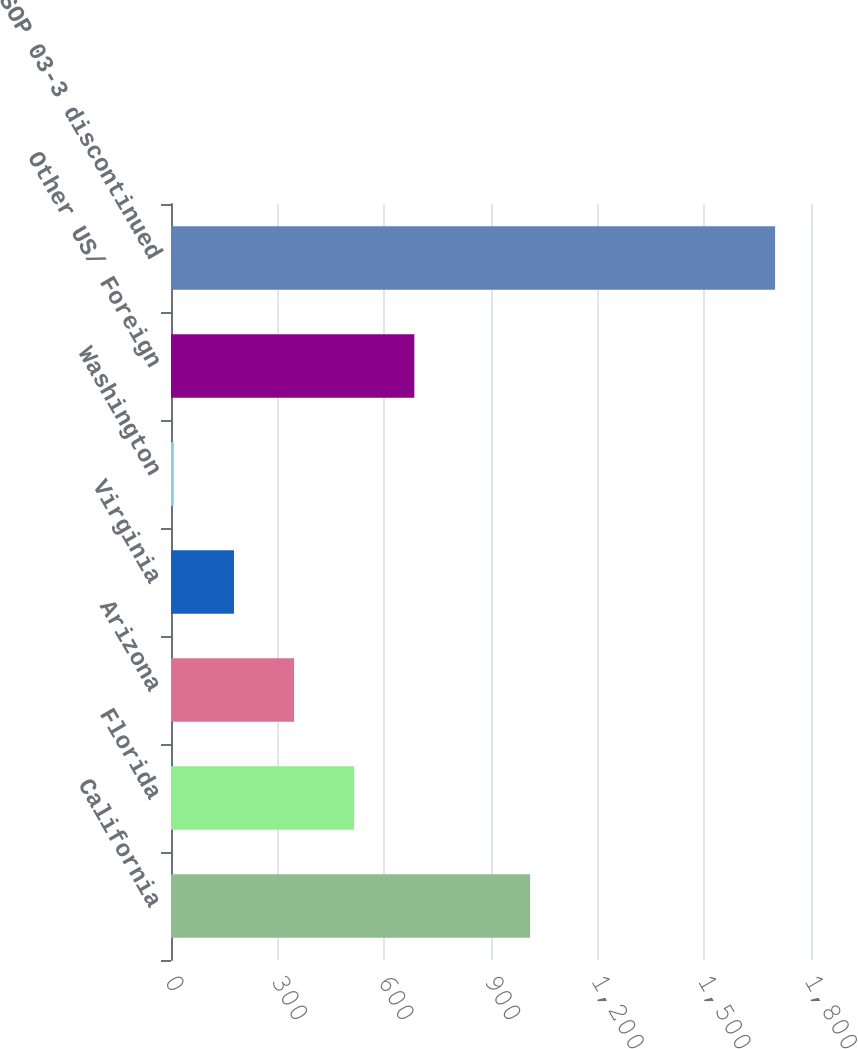Convert chart to OTSL. <chart><loc_0><loc_0><loc_500><loc_500><bar_chart><fcel>California<fcel>Florida<fcel>Arizona<fcel>Virginia<fcel>Washington<fcel>Other US/ Foreign<fcel>Total SOP 03-3 discontinued<nl><fcel>1010<fcel>515.3<fcel>346.2<fcel>177.1<fcel>8<fcel>684.4<fcel>1699<nl></chart> 